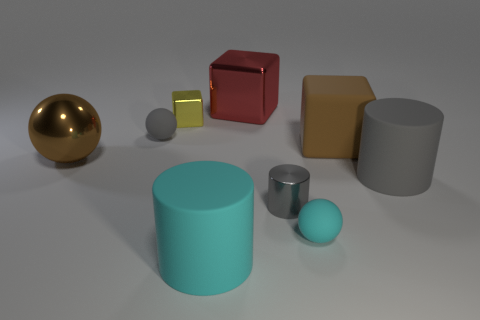What number of balls are either large gray rubber objects or small cyan rubber objects?
Provide a succinct answer. 1. There is a yellow thing that is the same shape as the big brown matte object; what material is it?
Provide a short and direct response. Metal. The yellow thing that is made of the same material as the small gray cylinder is what size?
Offer a terse response. Small. Is the shape of the gray rubber object in front of the brown matte block the same as the large shiny thing to the right of the big cyan matte cylinder?
Provide a succinct answer. No. What color is the big cylinder that is the same material as the large cyan thing?
Your answer should be compact. Gray. Does the gray object that is to the left of the big cyan rubber cylinder have the same size as the yellow shiny thing that is behind the tiny gray metallic cylinder?
Keep it short and to the point. Yes. What is the shape of the large matte thing that is both in front of the brown matte cube and right of the large metallic block?
Offer a terse response. Cylinder. Is there a small gray cylinder made of the same material as the small gray sphere?
Provide a succinct answer. No. There is a tiny object that is the same color as the small metal cylinder; what is its material?
Ensure brevity in your answer.  Rubber. Are the brown thing that is on the right side of the yellow block and the cyan thing that is on the right side of the shiny cylinder made of the same material?
Provide a succinct answer. Yes. 